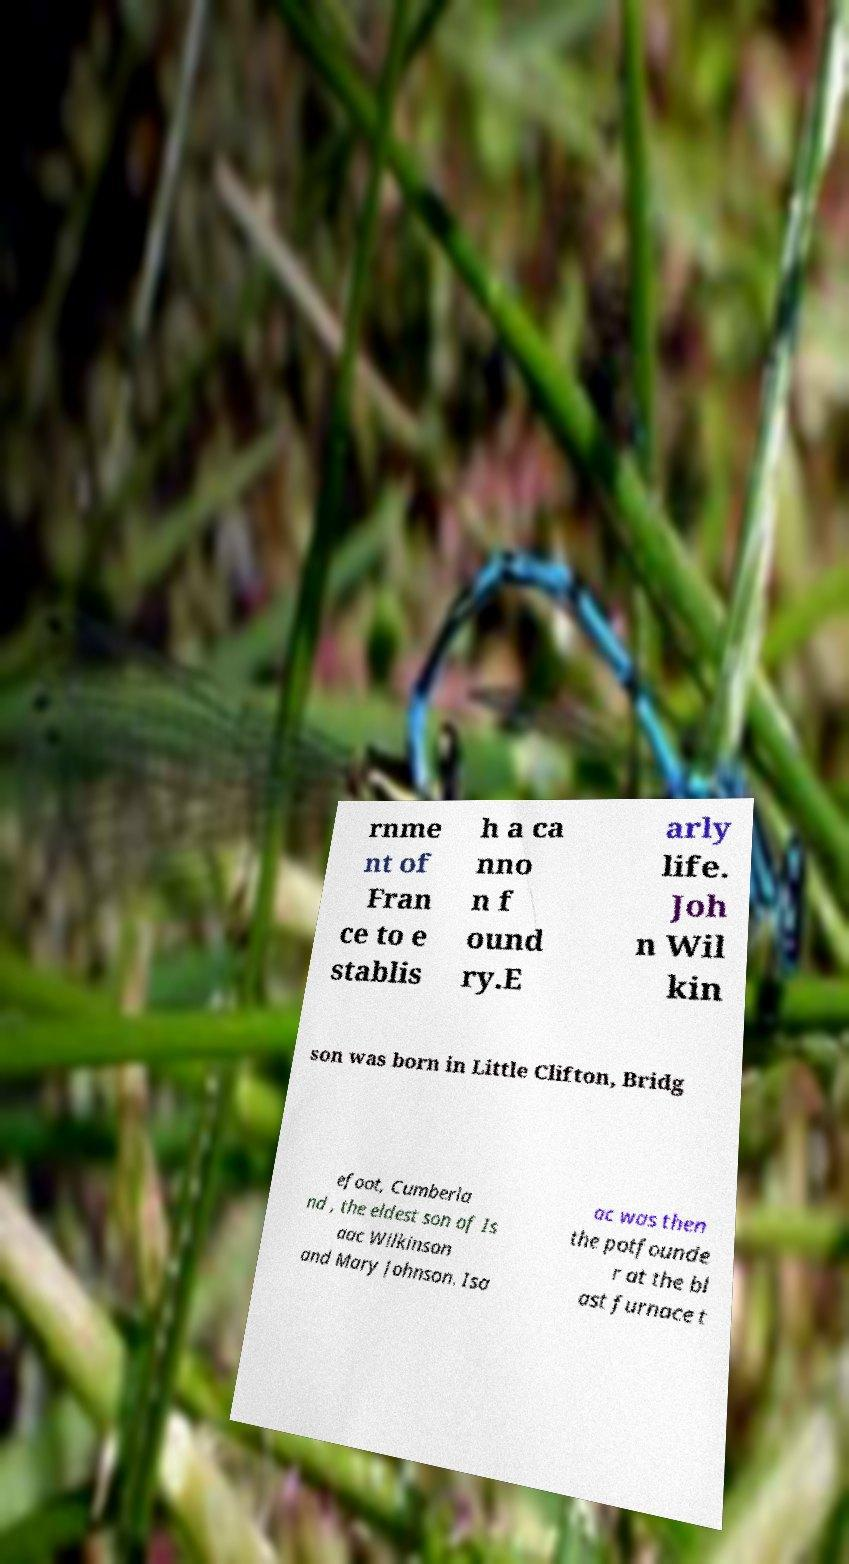Please identify and transcribe the text found in this image. rnme nt of Fran ce to e stablis h a ca nno n f ound ry.E arly life. Joh n Wil kin son was born in Little Clifton, Bridg efoot, Cumberla nd , the eldest son of Is aac Wilkinson and Mary Johnson. Isa ac was then the potfounde r at the bl ast furnace t 